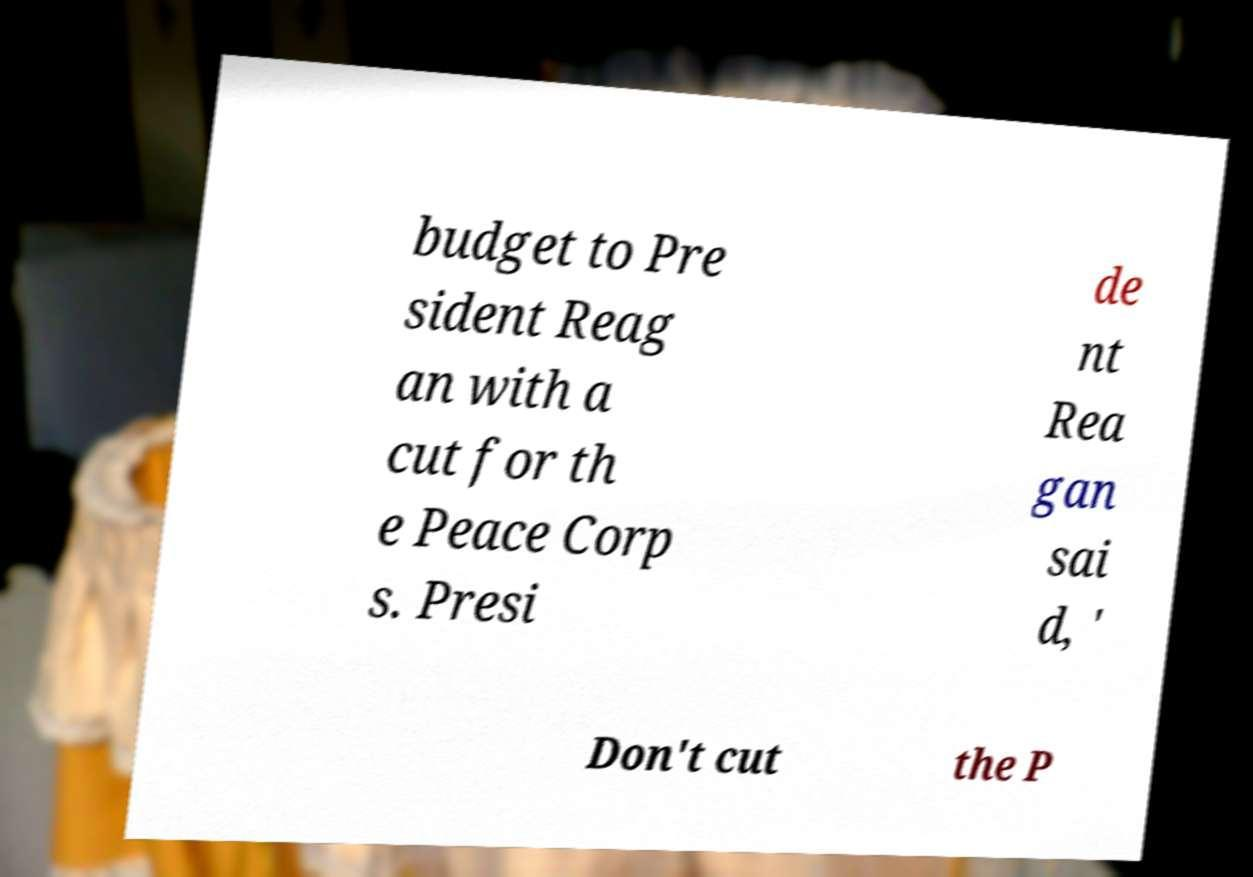Can you accurately transcribe the text from the provided image for me? budget to Pre sident Reag an with a cut for th e Peace Corp s. Presi de nt Rea gan sai d, ' Don't cut the P 